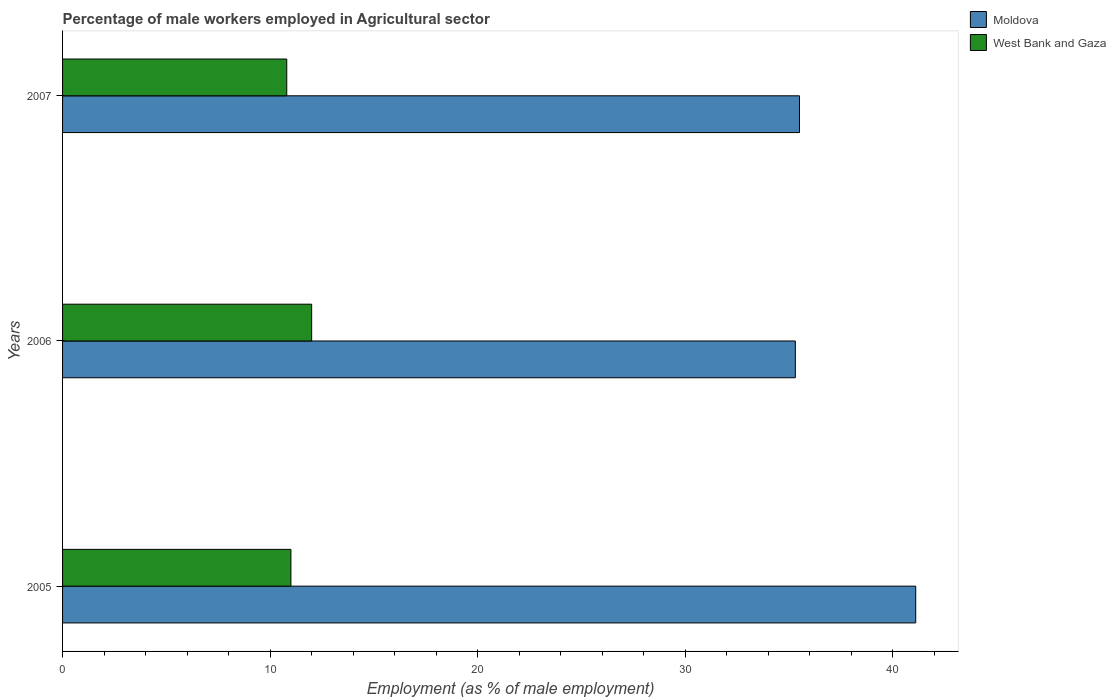How many groups of bars are there?
Make the answer very short. 3. How many bars are there on the 3rd tick from the top?
Give a very brief answer. 2. How many bars are there on the 3rd tick from the bottom?
Your response must be concise. 2. In how many cases, is the number of bars for a given year not equal to the number of legend labels?
Your answer should be very brief. 0. What is the percentage of male workers employed in Agricultural sector in West Bank and Gaza in 2005?
Your answer should be very brief. 11. Across all years, what is the maximum percentage of male workers employed in Agricultural sector in West Bank and Gaza?
Provide a succinct answer. 12. Across all years, what is the minimum percentage of male workers employed in Agricultural sector in West Bank and Gaza?
Keep it short and to the point. 10.8. In which year was the percentage of male workers employed in Agricultural sector in West Bank and Gaza maximum?
Provide a short and direct response. 2006. What is the total percentage of male workers employed in Agricultural sector in Moldova in the graph?
Keep it short and to the point. 111.9. What is the difference between the percentage of male workers employed in Agricultural sector in West Bank and Gaza in 2005 and the percentage of male workers employed in Agricultural sector in Moldova in 2007?
Offer a very short reply. -24.5. What is the average percentage of male workers employed in Agricultural sector in West Bank and Gaza per year?
Provide a short and direct response. 11.27. In the year 2007, what is the difference between the percentage of male workers employed in Agricultural sector in West Bank and Gaza and percentage of male workers employed in Agricultural sector in Moldova?
Your answer should be compact. -24.7. What is the ratio of the percentage of male workers employed in Agricultural sector in Moldova in 2005 to that in 2007?
Provide a succinct answer. 1.16. What is the difference between the highest and the second highest percentage of male workers employed in Agricultural sector in Moldova?
Your answer should be compact. 5.6. What is the difference between the highest and the lowest percentage of male workers employed in Agricultural sector in Moldova?
Your response must be concise. 5.8. Is the sum of the percentage of male workers employed in Agricultural sector in West Bank and Gaza in 2005 and 2006 greater than the maximum percentage of male workers employed in Agricultural sector in Moldova across all years?
Your answer should be compact. No. What does the 2nd bar from the top in 2007 represents?
Your answer should be compact. Moldova. What does the 2nd bar from the bottom in 2007 represents?
Offer a terse response. West Bank and Gaza. How many bars are there?
Offer a very short reply. 6. Are the values on the major ticks of X-axis written in scientific E-notation?
Ensure brevity in your answer.  No. Does the graph contain grids?
Make the answer very short. No. What is the title of the graph?
Give a very brief answer. Percentage of male workers employed in Agricultural sector. What is the label or title of the X-axis?
Your answer should be compact. Employment (as % of male employment). What is the Employment (as % of male employment) in Moldova in 2005?
Keep it short and to the point. 41.1. What is the Employment (as % of male employment) of West Bank and Gaza in 2005?
Offer a terse response. 11. What is the Employment (as % of male employment) of Moldova in 2006?
Offer a very short reply. 35.3. What is the Employment (as % of male employment) in Moldova in 2007?
Your answer should be very brief. 35.5. What is the Employment (as % of male employment) of West Bank and Gaza in 2007?
Provide a short and direct response. 10.8. Across all years, what is the maximum Employment (as % of male employment) of Moldova?
Your response must be concise. 41.1. Across all years, what is the maximum Employment (as % of male employment) in West Bank and Gaza?
Provide a succinct answer. 12. Across all years, what is the minimum Employment (as % of male employment) in Moldova?
Keep it short and to the point. 35.3. Across all years, what is the minimum Employment (as % of male employment) in West Bank and Gaza?
Ensure brevity in your answer.  10.8. What is the total Employment (as % of male employment) of Moldova in the graph?
Your response must be concise. 111.9. What is the total Employment (as % of male employment) of West Bank and Gaza in the graph?
Your response must be concise. 33.8. What is the difference between the Employment (as % of male employment) of Moldova in 2005 and that in 2006?
Your response must be concise. 5.8. What is the difference between the Employment (as % of male employment) in West Bank and Gaza in 2005 and that in 2006?
Give a very brief answer. -1. What is the difference between the Employment (as % of male employment) in West Bank and Gaza in 2005 and that in 2007?
Your answer should be compact. 0.2. What is the difference between the Employment (as % of male employment) in Moldova in 2006 and that in 2007?
Your answer should be very brief. -0.2. What is the difference between the Employment (as % of male employment) in Moldova in 2005 and the Employment (as % of male employment) in West Bank and Gaza in 2006?
Keep it short and to the point. 29.1. What is the difference between the Employment (as % of male employment) of Moldova in 2005 and the Employment (as % of male employment) of West Bank and Gaza in 2007?
Make the answer very short. 30.3. What is the difference between the Employment (as % of male employment) in Moldova in 2006 and the Employment (as % of male employment) in West Bank and Gaza in 2007?
Your answer should be very brief. 24.5. What is the average Employment (as % of male employment) in Moldova per year?
Provide a succinct answer. 37.3. What is the average Employment (as % of male employment) in West Bank and Gaza per year?
Keep it short and to the point. 11.27. In the year 2005, what is the difference between the Employment (as % of male employment) in Moldova and Employment (as % of male employment) in West Bank and Gaza?
Your answer should be very brief. 30.1. In the year 2006, what is the difference between the Employment (as % of male employment) in Moldova and Employment (as % of male employment) in West Bank and Gaza?
Make the answer very short. 23.3. In the year 2007, what is the difference between the Employment (as % of male employment) of Moldova and Employment (as % of male employment) of West Bank and Gaza?
Your response must be concise. 24.7. What is the ratio of the Employment (as % of male employment) of Moldova in 2005 to that in 2006?
Give a very brief answer. 1.16. What is the ratio of the Employment (as % of male employment) of Moldova in 2005 to that in 2007?
Keep it short and to the point. 1.16. What is the ratio of the Employment (as % of male employment) of West Bank and Gaza in 2005 to that in 2007?
Provide a succinct answer. 1.02. What is the difference between the highest and the lowest Employment (as % of male employment) in West Bank and Gaza?
Your answer should be compact. 1.2. 